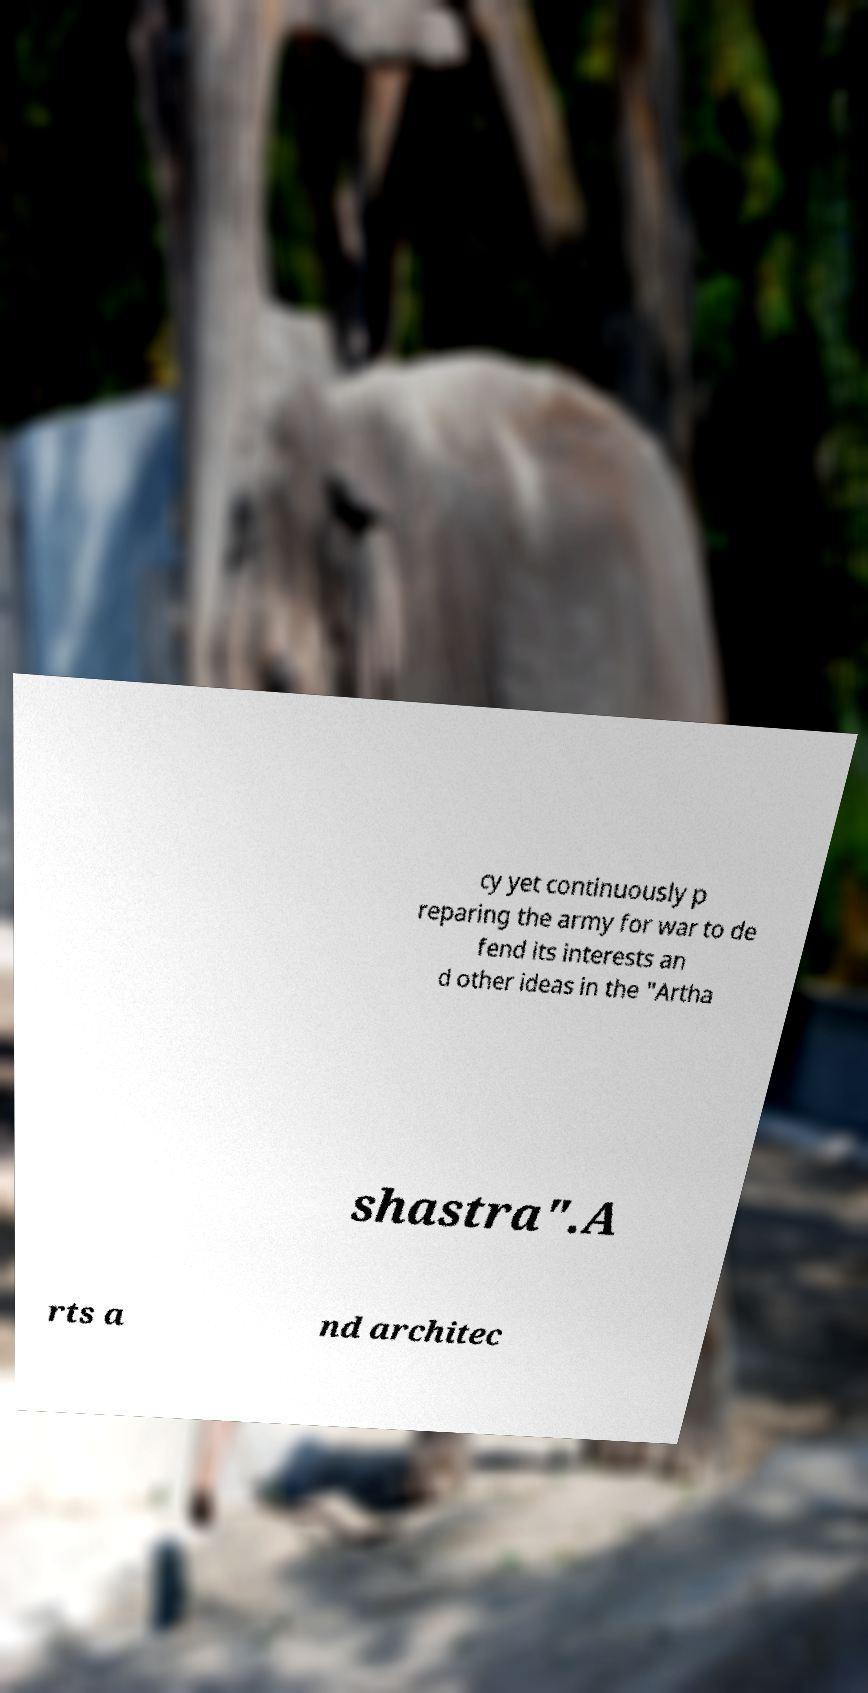What messages or text are displayed in this image? I need them in a readable, typed format. cy yet continuously p reparing the army for war to de fend its interests an d other ideas in the "Artha shastra".A rts a nd architec 